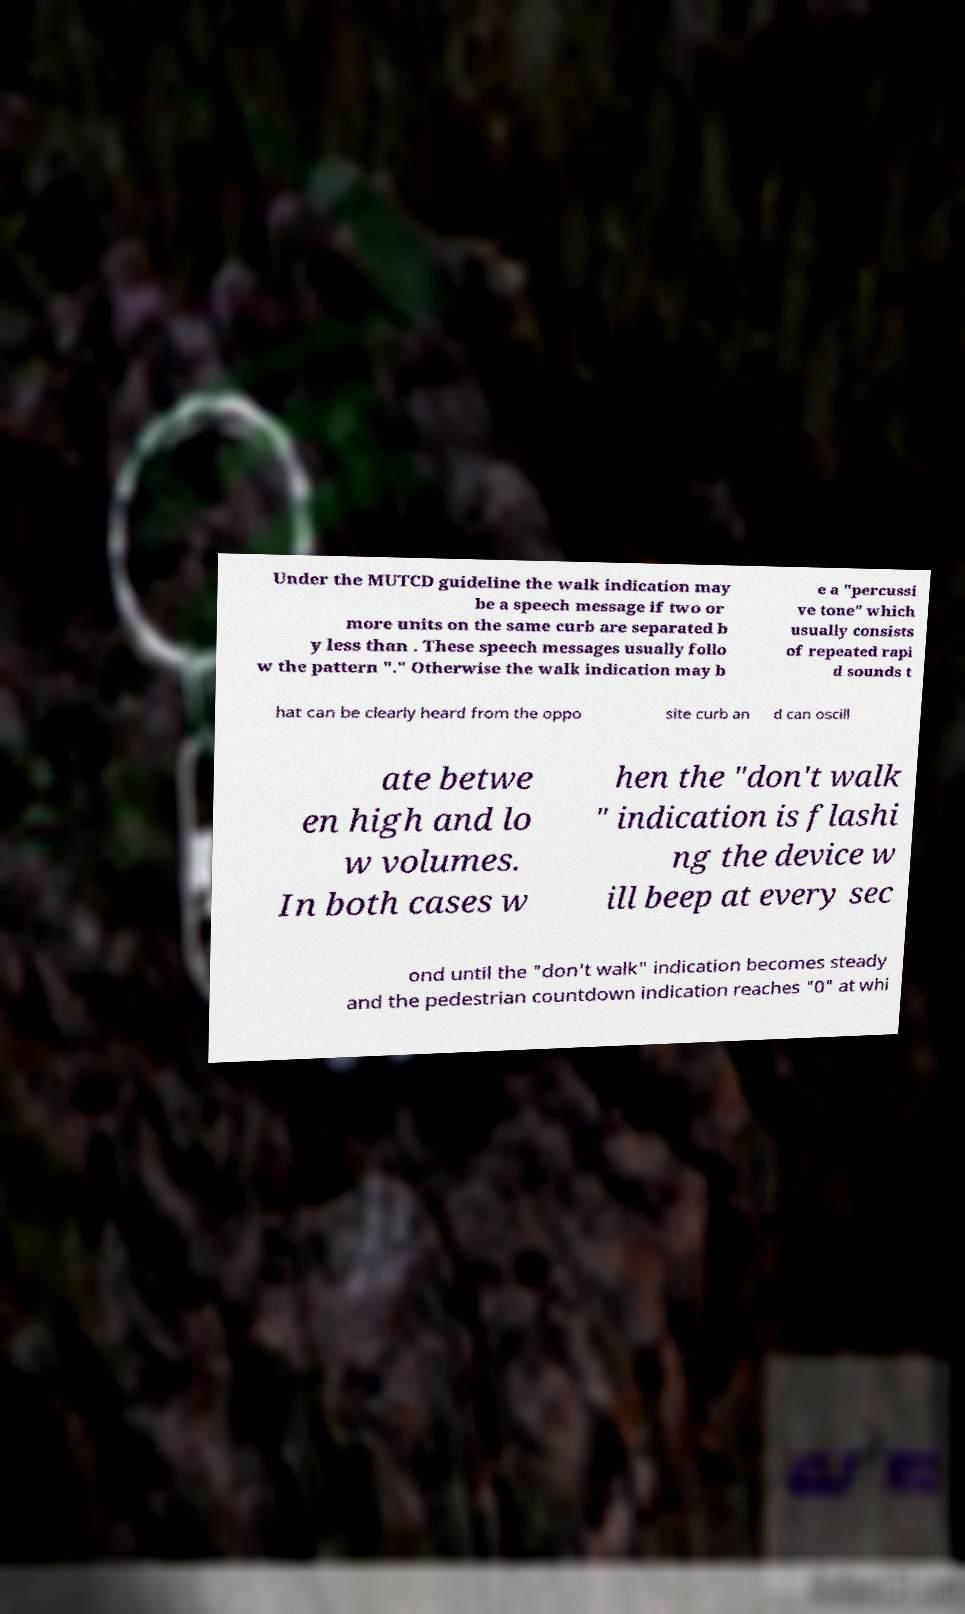Can you read and provide the text displayed in the image?This photo seems to have some interesting text. Can you extract and type it out for me? Under the MUTCD guideline the walk indication may be a speech message if two or more units on the same curb are separated b y less than . These speech messages usually follo w the pattern "." Otherwise the walk indication may b e a "percussi ve tone" which usually consists of repeated rapi d sounds t hat can be clearly heard from the oppo site curb an d can oscill ate betwe en high and lo w volumes. In both cases w hen the "don't walk " indication is flashi ng the device w ill beep at every sec ond until the "don't walk" indication becomes steady and the pedestrian countdown indication reaches "0" at whi 